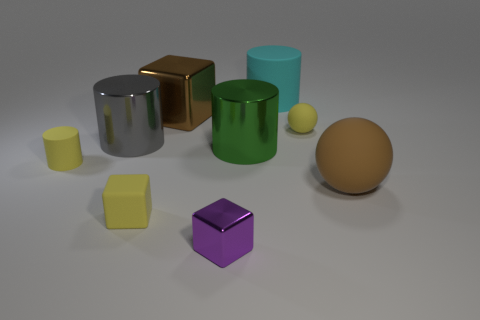Is the brown metallic thing the same size as the cyan rubber object?
Your answer should be compact. Yes. There is a metallic thing that is the same color as the large rubber sphere; what is its shape?
Provide a short and direct response. Cube. There is a purple thing; is it the same size as the block that is behind the big brown matte thing?
Your answer should be very brief. No. There is a rubber thing that is both on the right side of the large cyan cylinder and in front of the small cylinder; what is its color?
Offer a terse response. Brown. Is the number of metal cubes that are behind the large ball greater than the number of green things in front of the tiny yellow matte cylinder?
Make the answer very short. Yes. What is the size of the yellow cylinder that is the same material as the big sphere?
Ensure brevity in your answer.  Small. How many big brown cubes are right of the shiny block that is behind the yellow cylinder?
Make the answer very short. 0. Are there any large rubber things of the same shape as the tiny metallic thing?
Your answer should be very brief. No. The rubber sphere that is behind the rubber cylinder that is left of the big gray thing is what color?
Offer a very short reply. Yellow. Are there more yellow objects than large brown matte cylinders?
Provide a succinct answer. Yes. 